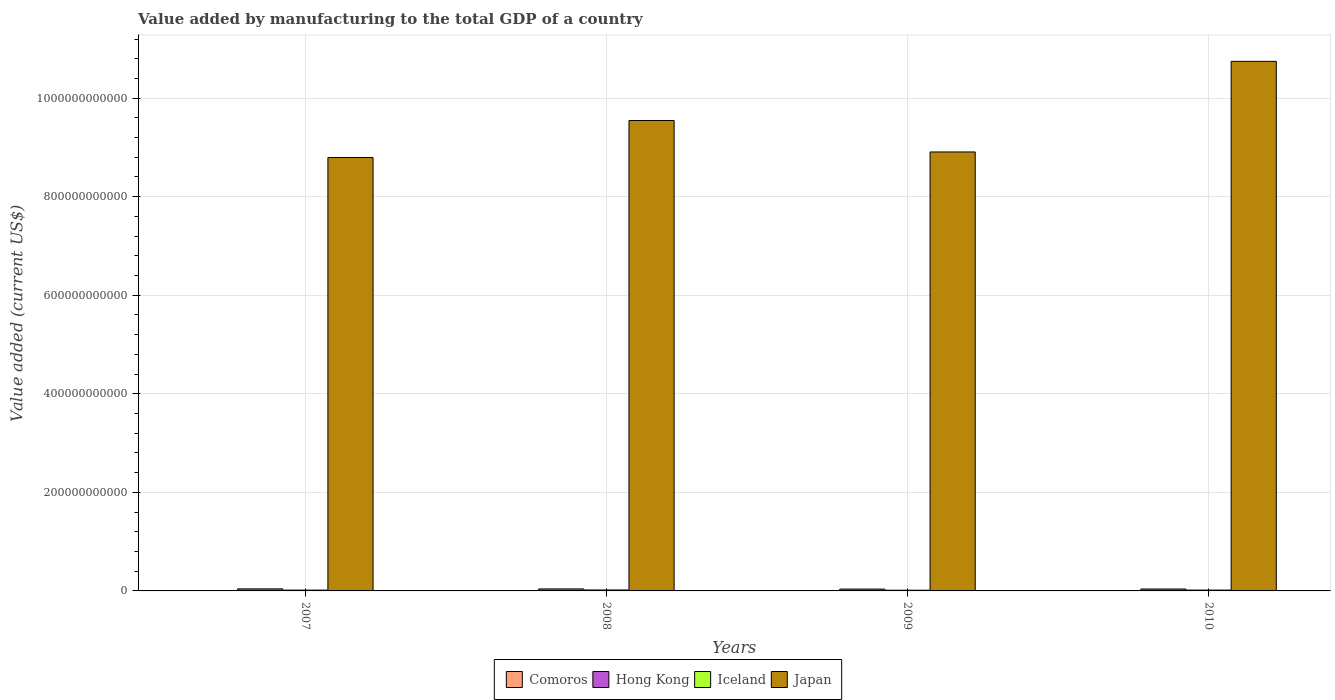How many groups of bars are there?
Your answer should be compact. 4. Are the number of bars per tick equal to the number of legend labels?
Ensure brevity in your answer.  Yes. Are the number of bars on each tick of the X-axis equal?
Provide a succinct answer. Yes. How many bars are there on the 3rd tick from the left?
Make the answer very short. 4. What is the label of the 2nd group of bars from the left?
Keep it short and to the point. 2008. What is the value added by manufacturing to the total GDP in Comoros in 2009?
Your response must be concise. 2.56e+07. Across all years, what is the maximum value added by manufacturing to the total GDP in Hong Kong?
Offer a very short reply. 4.15e+09. Across all years, what is the minimum value added by manufacturing to the total GDP in Comoros?
Keep it short and to the point. 1.89e+07. What is the total value added by manufacturing to the total GDP in Iceland in the graph?
Your answer should be very brief. 6.71e+09. What is the difference between the value added by manufacturing to the total GDP in Comoros in 2009 and that in 2010?
Your answer should be compact. -2.14e+06. What is the difference between the value added by manufacturing to the total GDP in Japan in 2008 and the value added by manufacturing to the total GDP in Comoros in 2010?
Provide a succinct answer. 9.55e+11. What is the average value added by manufacturing to the total GDP in Hong Kong per year?
Provide a succinct answer. 3.95e+09. In the year 2007, what is the difference between the value added by manufacturing to the total GDP in Iceland and value added by manufacturing to the total GDP in Hong Kong?
Offer a very short reply. -2.51e+09. What is the ratio of the value added by manufacturing to the total GDP in Comoros in 2009 to that in 2010?
Provide a succinct answer. 0.92. Is the difference between the value added by manufacturing to the total GDP in Iceland in 2008 and 2010 greater than the difference between the value added by manufacturing to the total GDP in Hong Kong in 2008 and 2010?
Provide a short and direct response. Yes. What is the difference between the highest and the second highest value added by manufacturing to the total GDP in Iceland?
Your answer should be very brief. 2.16e+08. What is the difference between the highest and the lowest value added by manufacturing to the total GDP in Comoros?
Make the answer very short. 8.85e+06. What does the 1st bar from the left in 2010 represents?
Provide a succinct answer. Comoros. Are all the bars in the graph horizontal?
Ensure brevity in your answer.  No. What is the difference between two consecutive major ticks on the Y-axis?
Your answer should be compact. 2.00e+11. How many legend labels are there?
Provide a succinct answer. 4. How are the legend labels stacked?
Your answer should be compact. Horizontal. What is the title of the graph?
Give a very brief answer. Value added by manufacturing to the total GDP of a country. Does "Iceland" appear as one of the legend labels in the graph?
Your answer should be very brief. Yes. What is the label or title of the X-axis?
Your answer should be compact. Years. What is the label or title of the Y-axis?
Make the answer very short. Value added (current US$). What is the Value added (current US$) in Comoros in 2007?
Provide a short and direct response. 1.89e+07. What is the Value added (current US$) in Hong Kong in 2007?
Provide a short and direct response. 4.15e+09. What is the Value added (current US$) of Iceland in 2007?
Provide a short and direct response. 1.64e+09. What is the Value added (current US$) of Japan in 2007?
Provide a succinct answer. 8.80e+11. What is the Value added (current US$) in Comoros in 2008?
Your answer should be compact. 1.98e+07. What is the Value added (current US$) of Hong Kong in 2008?
Your answer should be compact. 4.05e+09. What is the Value added (current US$) in Iceland in 2008?
Provide a short and direct response. 1.92e+09. What is the Value added (current US$) of Japan in 2008?
Ensure brevity in your answer.  9.55e+11. What is the Value added (current US$) in Comoros in 2009?
Give a very brief answer. 2.56e+07. What is the Value added (current US$) of Hong Kong in 2009?
Provide a short and direct response. 3.70e+09. What is the Value added (current US$) in Iceland in 2009?
Ensure brevity in your answer.  1.45e+09. What is the Value added (current US$) in Japan in 2009?
Provide a short and direct response. 8.91e+11. What is the Value added (current US$) in Comoros in 2010?
Your answer should be compact. 2.77e+07. What is the Value added (current US$) of Hong Kong in 2010?
Give a very brief answer. 3.91e+09. What is the Value added (current US$) of Iceland in 2010?
Provide a succinct answer. 1.71e+09. What is the Value added (current US$) in Japan in 2010?
Offer a terse response. 1.07e+12. Across all years, what is the maximum Value added (current US$) of Comoros?
Make the answer very short. 2.77e+07. Across all years, what is the maximum Value added (current US$) of Hong Kong?
Provide a short and direct response. 4.15e+09. Across all years, what is the maximum Value added (current US$) in Iceland?
Your answer should be compact. 1.92e+09. Across all years, what is the maximum Value added (current US$) in Japan?
Offer a very short reply. 1.07e+12. Across all years, what is the minimum Value added (current US$) in Comoros?
Your answer should be compact. 1.89e+07. Across all years, what is the minimum Value added (current US$) in Hong Kong?
Make the answer very short. 3.70e+09. Across all years, what is the minimum Value added (current US$) of Iceland?
Provide a succinct answer. 1.45e+09. Across all years, what is the minimum Value added (current US$) of Japan?
Ensure brevity in your answer.  8.80e+11. What is the total Value added (current US$) in Comoros in the graph?
Keep it short and to the point. 9.19e+07. What is the total Value added (current US$) in Hong Kong in the graph?
Give a very brief answer. 1.58e+1. What is the total Value added (current US$) in Iceland in the graph?
Make the answer very short. 6.71e+09. What is the total Value added (current US$) of Japan in the graph?
Your response must be concise. 3.80e+12. What is the difference between the Value added (current US$) of Comoros in 2007 and that in 2008?
Provide a succinct answer. -9.48e+05. What is the difference between the Value added (current US$) of Hong Kong in 2007 and that in 2008?
Keep it short and to the point. 1.03e+08. What is the difference between the Value added (current US$) in Iceland in 2007 and that in 2008?
Provide a succinct answer. -2.86e+08. What is the difference between the Value added (current US$) in Japan in 2007 and that in 2008?
Offer a terse response. -7.51e+1. What is the difference between the Value added (current US$) of Comoros in 2007 and that in 2009?
Your answer should be very brief. -6.71e+06. What is the difference between the Value added (current US$) of Hong Kong in 2007 and that in 2009?
Ensure brevity in your answer.  4.44e+08. What is the difference between the Value added (current US$) in Iceland in 2007 and that in 2009?
Provide a succinct answer. 1.84e+08. What is the difference between the Value added (current US$) in Japan in 2007 and that in 2009?
Keep it short and to the point. -1.13e+1. What is the difference between the Value added (current US$) of Comoros in 2007 and that in 2010?
Make the answer very short. -8.85e+06. What is the difference between the Value added (current US$) in Hong Kong in 2007 and that in 2010?
Give a very brief answer. 2.34e+08. What is the difference between the Value added (current US$) in Iceland in 2007 and that in 2010?
Ensure brevity in your answer.  -7.01e+07. What is the difference between the Value added (current US$) in Japan in 2007 and that in 2010?
Provide a succinct answer. -1.95e+11. What is the difference between the Value added (current US$) in Comoros in 2008 and that in 2009?
Provide a succinct answer. -5.76e+06. What is the difference between the Value added (current US$) of Hong Kong in 2008 and that in 2009?
Your response must be concise. 3.42e+08. What is the difference between the Value added (current US$) in Iceland in 2008 and that in 2009?
Provide a succinct answer. 4.70e+08. What is the difference between the Value added (current US$) of Japan in 2008 and that in 2009?
Ensure brevity in your answer.  6.38e+1. What is the difference between the Value added (current US$) in Comoros in 2008 and that in 2010?
Make the answer very short. -7.90e+06. What is the difference between the Value added (current US$) of Hong Kong in 2008 and that in 2010?
Keep it short and to the point. 1.32e+08. What is the difference between the Value added (current US$) of Iceland in 2008 and that in 2010?
Provide a succinct answer. 2.16e+08. What is the difference between the Value added (current US$) in Japan in 2008 and that in 2010?
Your response must be concise. -1.20e+11. What is the difference between the Value added (current US$) in Comoros in 2009 and that in 2010?
Your answer should be very brief. -2.14e+06. What is the difference between the Value added (current US$) in Hong Kong in 2009 and that in 2010?
Your response must be concise. -2.10e+08. What is the difference between the Value added (current US$) in Iceland in 2009 and that in 2010?
Provide a short and direct response. -2.54e+08. What is the difference between the Value added (current US$) in Japan in 2009 and that in 2010?
Ensure brevity in your answer.  -1.84e+11. What is the difference between the Value added (current US$) in Comoros in 2007 and the Value added (current US$) in Hong Kong in 2008?
Give a very brief answer. -4.03e+09. What is the difference between the Value added (current US$) in Comoros in 2007 and the Value added (current US$) in Iceland in 2008?
Give a very brief answer. -1.90e+09. What is the difference between the Value added (current US$) in Comoros in 2007 and the Value added (current US$) in Japan in 2008?
Provide a succinct answer. -9.55e+11. What is the difference between the Value added (current US$) of Hong Kong in 2007 and the Value added (current US$) of Iceland in 2008?
Ensure brevity in your answer.  2.23e+09. What is the difference between the Value added (current US$) of Hong Kong in 2007 and the Value added (current US$) of Japan in 2008?
Offer a very short reply. -9.50e+11. What is the difference between the Value added (current US$) in Iceland in 2007 and the Value added (current US$) in Japan in 2008?
Your answer should be compact. -9.53e+11. What is the difference between the Value added (current US$) in Comoros in 2007 and the Value added (current US$) in Hong Kong in 2009?
Keep it short and to the point. -3.69e+09. What is the difference between the Value added (current US$) of Comoros in 2007 and the Value added (current US$) of Iceland in 2009?
Provide a succinct answer. -1.43e+09. What is the difference between the Value added (current US$) in Comoros in 2007 and the Value added (current US$) in Japan in 2009?
Offer a terse response. -8.91e+11. What is the difference between the Value added (current US$) in Hong Kong in 2007 and the Value added (current US$) in Iceland in 2009?
Offer a very short reply. 2.70e+09. What is the difference between the Value added (current US$) in Hong Kong in 2007 and the Value added (current US$) in Japan in 2009?
Give a very brief answer. -8.87e+11. What is the difference between the Value added (current US$) of Iceland in 2007 and the Value added (current US$) of Japan in 2009?
Provide a succinct answer. -8.89e+11. What is the difference between the Value added (current US$) of Comoros in 2007 and the Value added (current US$) of Hong Kong in 2010?
Your response must be concise. -3.90e+09. What is the difference between the Value added (current US$) of Comoros in 2007 and the Value added (current US$) of Iceland in 2010?
Offer a terse response. -1.69e+09. What is the difference between the Value added (current US$) of Comoros in 2007 and the Value added (current US$) of Japan in 2010?
Provide a succinct answer. -1.07e+12. What is the difference between the Value added (current US$) of Hong Kong in 2007 and the Value added (current US$) of Iceland in 2010?
Make the answer very short. 2.44e+09. What is the difference between the Value added (current US$) in Hong Kong in 2007 and the Value added (current US$) in Japan in 2010?
Ensure brevity in your answer.  -1.07e+12. What is the difference between the Value added (current US$) of Iceland in 2007 and the Value added (current US$) of Japan in 2010?
Your response must be concise. -1.07e+12. What is the difference between the Value added (current US$) of Comoros in 2008 and the Value added (current US$) of Hong Kong in 2009?
Ensure brevity in your answer.  -3.68e+09. What is the difference between the Value added (current US$) in Comoros in 2008 and the Value added (current US$) in Iceland in 2009?
Your answer should be compact. -1.43e+09. What is the difference between the Value added (current US$) in Comoros in 2008 and the Value added (current US$) in Japan in 2009?
Give a very brief answer. -8.91e+11. What is the difference between the Value added (current US$) in Hong Kong in 2008 and the Value added (current US$) in Iceland in 2009?
Provide a short and direct response. 2.59e+09. What is the difference between the Value added (current US$) of Hong Kong in 2008 and the Value added (current US$) of Japan in 2009?
Make the answer very short. -8.87e+11. What is the difference between the Value added (current US$) in Iceland in 2008 and the Value added (current US$) in Japan in 2009?
Ensure brevity in your answer.  -8.89e+11. What is the difference between the Value added (current US$) of Comoros in 2008 and the Value added (current US$) of Hong Kong in 2010?
Your answer should be very brief. -3.89e+09. What is the difference between the Value added (current US$) of Comoros in 2008 and the Value added (current US$) of Iceland in 2010?
Give a very brief answer. -1.69e+09. What is the difference between the Value added (current US$) of Comoros in 2008 and the Value added (current US$) of Japan in 2010?
Keep it short and to the point. -1.07e+12. What is the difference between the Value added (current US$) in Hong Kong in 2008 and the Value added (current US$) in Iceland in 2010?
Provide a short and direct response. 2.34e+09. What is the difference between the Value added (current US$) of Hong Kong in 2008 and the Value added (current US$) of Japan in 2010?
Your answer should be compact. -1.07e+12. What is the difference between the Value added (current US$) of Iceland in 2008 and the Value added (current US$) of Japan in 2010?
Keep it short and to the point. -1.07e+12. What is the difference between the Value added (current US$) in Comoros in 2009 and the Value added (current US$) in Hong Kong in 2010?
Your answer should be very brief. -3.89e+09. What is the difference between the Value added (current US$) of Comoros in 2009 and the Value added (current US$) of Iceland in 2010?
Your response must be concise. -1.68e+09. What is the difference between the Value added (current US$) in Comoros in 2009 and the Value added (current US$) in Japan in 2010?
Your answer should be very brief. -1.07e+12. What is the difference between the Value added (current US$) in Hong Kong in 2009 and the Value added (current US$) in Iceland in 2010?
Provide a short and direct response. 2.00e+09. What is the difference between the Value added (current US$) in Hong Kong in 2009 and the Value added (current US$) in Japan in 2010?
Make the answer very short. -1.07e+12. What is the difference between the Value added (current US$) of Iceland in 2009 and the Value added (current US$) of Japan in 2010?
Provide a short and direct response. -1.07e+12. What is the average Value added (current US$) of Comoros per year?
Provide a short and direct response. 2.30e+07. What is the average Value added (current US$) in Hong Kong per year?
Your response must be concise. 3.95e+09. What is the average Value added (current US$) in Iceland per year?
Your answer should be very brief. 1.68e+09. What is the average Value added (current US$) in Japan per year?
Your answer should be very brief. 9.50e+11. In the year 2007, what is the difference between the Value added (current US$) in Comoros and Value added (current US$) in Hong Kong?
Your answer should be compact. -4.13e+09. In the year 2007, what is the difference between the Value added (current US$) in Comoros and Value added (current US$) in Iceland?
Your response must be concise. -1.62e+09. In the year 2007, what is the difference between the Value added (current US$) in Comoros and Value added (current US$) in Japan?
Keep it short and to the point. -8.79e+11. In the year 2007, what is the difference between the Value added (current US$) of Hong Kong and Value added (current US$) of Iceland?
Offer a very short reply. 2.51e+09. In the year 2007, what is the difference between the Value added (current US$) of Hong Kong and Value added (current US$) of Japan?
Your response must be concise. -8.75e+11. In the year 2007, what is the difference between the Value added (current US$) of Iceland and Value added (current US$) of Japan?
Offer a terse response. -8.78e+11. In the year 2008, what is the difference between the Value added (current US$) in Comoros and Value added (current US$) in Hong Kong?
Give a very brief answer. -4.03e+09. In the year 2008, what is the difference between the Value added (current US$) of Comoros and Value added (current US$) of Iceland?
Your response must be concise. -1.90e+09. In the year 2008, what is the difference between the Value added (current US$) in Comoros and Value added (current US$) in Japan?
Make the answer very short. -9.55e+11. In the year 2008, what is the difference between the Value added (current US$) of Hong Kong and Value added (current US$) of Iceland?
Your answer should be very brief. 2.12e+09. In the year 2008, what is the difference between the Value added (current US$) of Hong Kong and Value added (current US$) of Japan?
Your response must be concise. -9.51e+11. In the year 2008, what is the difference between the Value added (current US$) in Iceland and Value added (current US$) in Japan?
Ensure brevity in your answer.  -9.53e+11. In the year 2009, what is the difference between the Value added (current US$) in Comoros and Value added (current US$) in Hong Kong?
Your response must be concise. -3.68e+09. In the year 2009, what is the difference between the Value added (current US$) in Comoros and Value added (current US$) in Iceland?
Your response must be concise. -1.43e+09. In the year 2009, what is the difference between the Value added (current US$) in Comoros and Value added (current US$) in Japan?
Ensure brevity in your answer.  -8.91e+11. In the year 2009, what is the difference between the Value added (current US$) of Hong Kong and Value added (current US$) of Iceland?
Your answer should be compact. 2.25e+09. In the year 2009, what is the difference between the Value added (current US$) in Hong Kong and Value added (current US$) in Japan?
Your response must be concise. -8.87e+11. In the year 2009, what is the difference between the Value added (current US$) in Iceland and Value added (current US$) in Japan?
Your answer should be compact. -8.89e+11. In the year 2010, what is the difference between the Value added (current US$) of Comoros and Value added (current US$) of Hong Kong?
Ensure brevity in your answer.  -3.89e+09. In the year 2010, what is the difference between the Value added (current US$) in Comoros and Value added (current US$) in Iceland?
Ensure brevity in your answer.  -1.68e+09. In the year 2010, what is the difference between the Value added (current US$) in Comoros and Value added (current US$) in Japan?
Your answer should be compact. -1.07e+12. In the year 2010, what is the difference between the Value added (current US$) in Hong Kong and Value added (current US$) in Iceland?
Provide a short and direct response. 2.21e+09. In the year 2010, what is the difference between the Value added (current US$) in Hong Kong and Value added (current US$) in Japan?
Make the answer very short. -1.07e+12. In the year 2010, what is the difference between the Value added (current US$) of Iceland and Value added (current US$) of Japan?
Your response must be concise. -1.07e+12. What is the ratio of the Value added (current US$) in Comoros in 2007 to that in 2008?
Give a very brief answer. 0.95. What is the ratio of the Value added (current US$) in Hong Kong in 2007 to that in 2008?
Your response must be concise. 1.03. What is the ratio of the Value added (current US$) of Iceland in 2007 to that in 2008?
Your response must be concise. 0.85. What is the ratio of the Value added (current US$) of Japan in 2007 to that in 2008?
Offer a terse response. 0.92. What is the ratio of the Value added (current US$) in Comoros in 2007 to that in 2009?
Offer a very short reply. 0.74. What is the ratio of the Value added (current US$) in Hong Kong in 2007 to that in 2009?
Provide a succinct answer. 1.12. What is the ratio of the Value added (current US$) of Iceland in 2007 to that in 2009?
Give a very brief answer. 1.13. What is the ratio of the Value added (current US$) of Japan in 2007 to that in 2009?
Ensure brevity in your answer.  0.99. What is the ratio of the Value added (current US$) in Comoros in 2007 to that in 2010?
Offer a terse response. 0.68. What is the ratio of the Value added (current US$) of Hong Kong in 2007 to that in 2010?
Your answer should be compact. 1.06. What is the ratio of the Value added (current US$) of Iceland in 2007 to that in 2010?
Give a very brief answer. 0.96. What is the ratio of the Value added (current US$) of Japan in 2007 to that in 2010?
Ensure brevity in your answer.  0.82. What is the ratio of the Value added (current US$) in Comoros in 2008 to that in 2009?
Your answer should be compact. 0.77. What is the ratio of the Value added (current US$) in Hong Kong in 2008 to that in 2009?
Your response must be concise. 1.09. What is the ratio of the Value added (current US$) in Iceland in 2008 to that in 2009?
Provide a short and direct response. 1.32. What is the ratio of the Value added (current US$) of Japan in 2008 to that in 2009?
Your answer should be very brief. 1.07. What is the ratio of the Value added (current US$) in Comoros in 2008 to that in 2010?
Offer a very short reply. 0.71. What is the ratio of the Value added (current US$) of Hong Kong in 2008 to that in 2010?
Your answer should be compact. 1.03. What is the ratio of the Value added (current US$) in Iceland in 2008 to that in 2010?
Your answer should be compact. 1.13. What is the ratio of the Value added (current US$) in Japan in 2008 to that in 2010?
Provide a succinct answer. 0.89. What is the ratio of the Value added (current US$) of Comoros in 2009 to that in 2010?
Offer a very short reply. 0.92. What is the ratio of the Value added (current US$) in Hong Kong in 2009 to that in 2010?
Offer a terse response. 0.95. What is the ratio of the Value added (current US$) of Iceland in 2009 to that in 2010?
Provide a short and direct response. 0.85. What is the ratio of the Value added (current US$) in Japan in 2009 to that in 2010?
Make the answer very short. 0.83. What is the difference between the highest and the second highest Value added (current US$) in Comoros?
Keep it short and to the point. 2.14e+06. What is the difference between the highest and the second highest Value added (current US$) in Hong Kong?
Offer a terse response. 1.03e+08. What is the difference between the highest and the second highest Value added (current US$) of Iceland?
Give a very brief answer. 2.16e+08. What is the difference between the highest and the second highest Value added (current US$) in Japan?
Offer a very short reply. 1.20e+11. What is the difference between the highest and the lowest Value added (current US$) of Comoros?
Offer a very short reply. 8.85e+06. What is the difference between the highest and the lowest Value added (current US$) in Hong Kong?
Give a very brief answer. 4.44e+08. What is the difference between the highest and the lowest Value added (current US$) of Iceland?
Make the answer very short. 4.70e+08. What is the difference between the highest and the lowest Value added (current US$) in Japan?
Make the answer very short. 1.95e+11. 